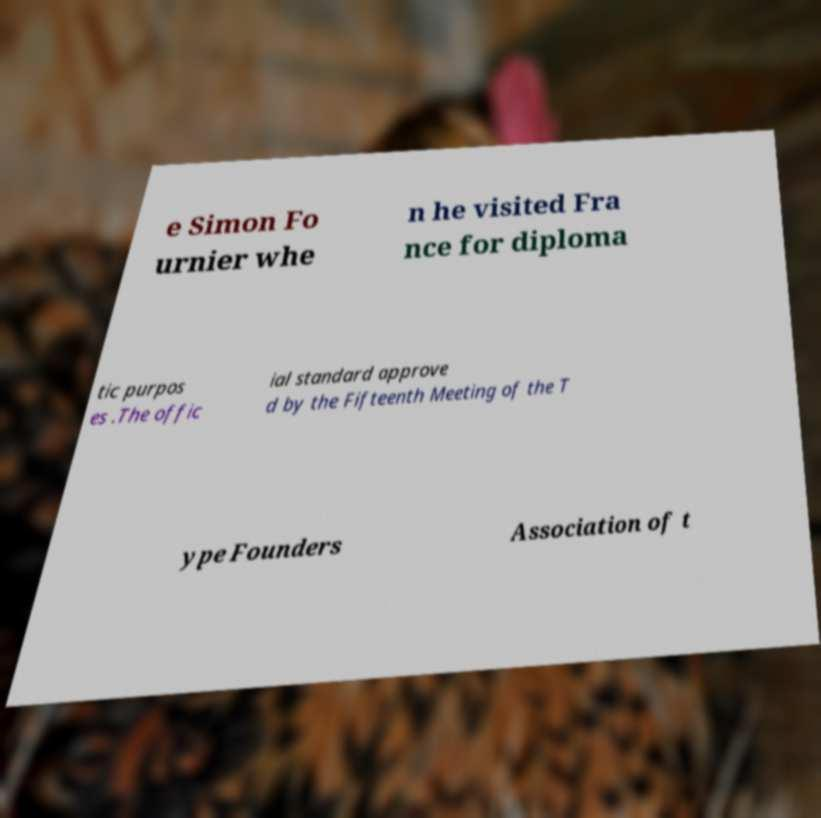Can you accurately transcribe the text from the provided image for me? e Simon Fo urnier whe n he visited Fra nce for diploma tic purpos es .The offic ial standard approve d by the Fifteenth Meeting of the T ype Founders Association of t 